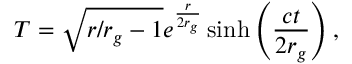<formula> <loc_0><loc_0><loc_500><loc_500>T = \sqrt { r / r _ { g } - 1 } e ^ { \frac { r } { 2 r _ { g } } } \sinh \left ( \frac { c t } { 2 r _ { g } } \right ) ,</formula> 